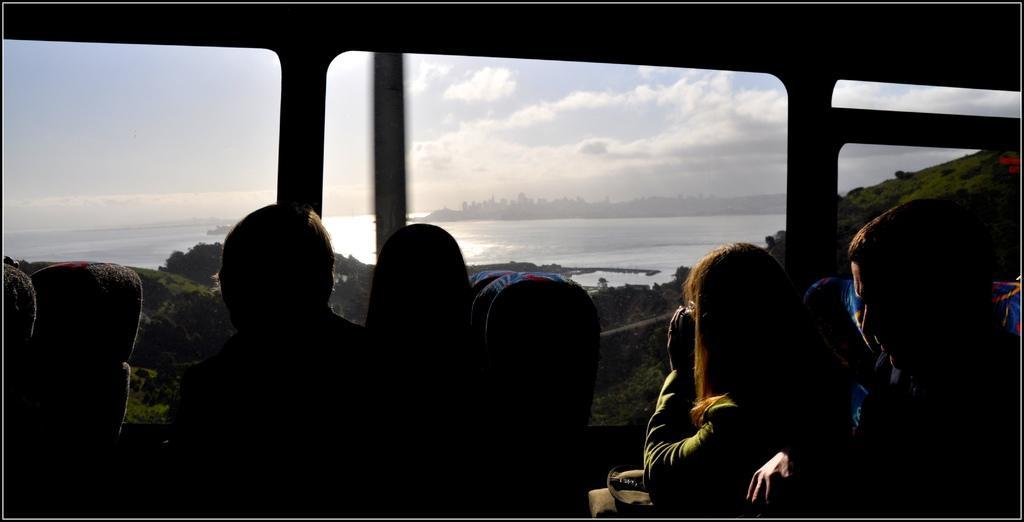Describe this image in one or two sentences. This picture shows few people seated and we see water and buildings and a cloudy Sky from the glass of the vehicle. 